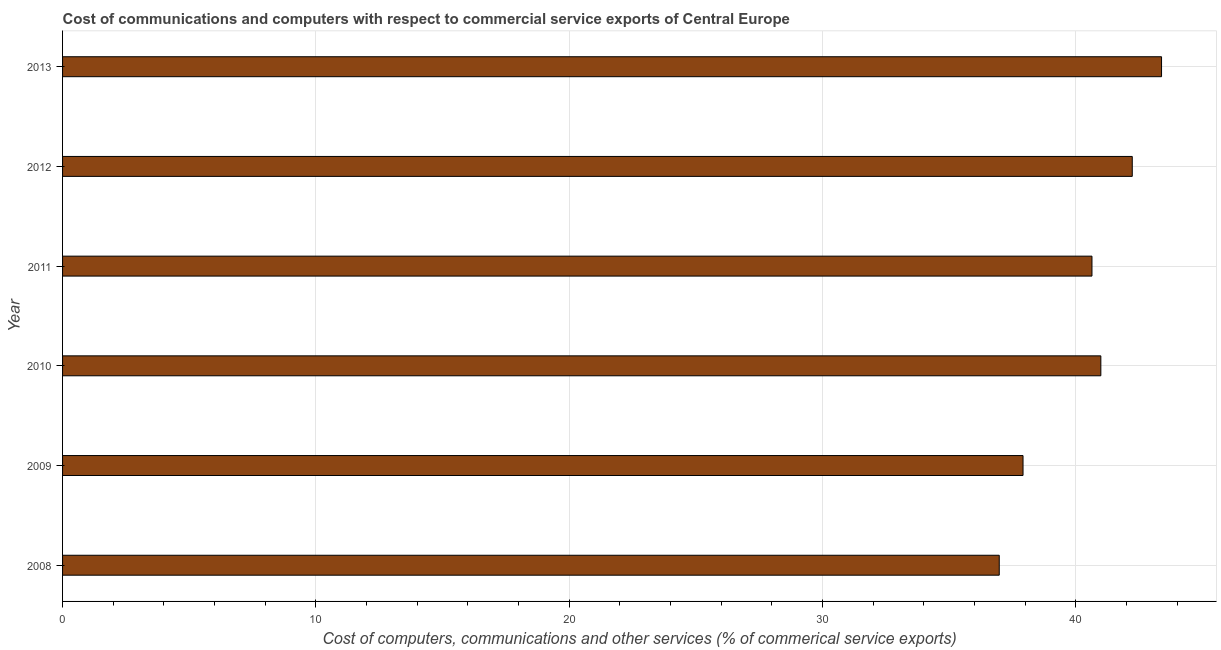Does the graph contain any zero values?
Your answer should be very brief. No. Does the graph contain grids?
Make the answer very short. Yes. What is the title of the graph?
Provide a succinct answer. Cost of communications and computers with respect to commercial service exports of Central Europe. What is the label or title of the X-axis?
Offer a very short reply. Cost of computers, communications and other services (% of commerical service exports). What is the cost of communications in 2010?
Offer a terse response. 40.99. Across all years, what is the maximum cost of communications?
Your response must be concise. 43.38. Across all years, what is the minimum  computer and other services?
Keep it short and to the point. 36.98. What is the sum of the  computer and other services?
Your response must be concise. 242.12. What is the difference between the  computer and other services in 2009 and 2011?
Your response must be concise. -2.72. What is the average cost of communications per year?
Provide a short and direct response. 40.35. What is the median  computer and other services?
Offer a terse response. 40.81. In how many years, is the cost of communications greater than 18 %?
Give a very brief answer. 6. Do a majority of the years between 2009 and 2011 (inclusive) have  computer and other services greater than 24 %?
Your answer should be very brief. Yes. What is the ratio of the  computer and other services in 2008 to that in 2010?
Provide a succinct answer. 0.9. Is the cost of communications in 2008 less than that in 2009?
Offer a very short reply. Yes. Is the difference between the  computer and other services in 2008 and 2009 greater than the difference between any two years?
Your response must be concise. No. What is the difference between the highest and the second highest  computer and other services?
Offer a very short reply. 1.16. Is the sum of the cost of communications in 2008 and 2010 greater than the maximum cost of communications across all years?
Offer a terse response. Yes. What is the difference between the highest and the lowest cost of communications?
Give a very brief answer. 6.41. In how many years, is the cost of communications greater than the average cost of communications taken over all years?
Your response must be concise. 4. Are all the bars in the graph horizontal?
Provide a short and direct response. Yes. What is the difference between two consecutive major ticks on the X-axis?
Give a very brief answer. 10. Are the values on the major ticks of X-axis written in scientific E-notation?
Provide a succinct answer. No. What is the Cost of computers, communications and other services (% of commerical service exports) of 2008?
Your response must be concise. 36.98. What is the Cost of computers, communications and other services (% of commerical service exports) in 2009?
Keep it short and to the point. 37.91. What is the Cost of computers, communications and other services (% of commerical service exports) of 2010?
Your response must be concise. 40.99. What is the Cost of computers, communications and other services (% of commerical service exports) of 2011?
Provide a succinct answer. 40.64. What is the Cost of computers, communications and other services (% of commerical service exports) in 2012?
Your response must be concise. 42.23. What is the Cost of computers, communications and other services (% of commerical service exports) of 2013?
Keep it short and to the point. 43.38. What is the difference between the Cost of computers, communications and other services (% of commerical service exports) in 2008 and 2009?
Your answer should be compact. -0.94. What is the difference between the Cost of computers, communications and other services (% of commerical service exports) in 2008 and 2010?
Give a very brief answer. -4.01. What is the difference between the Cost of computers, communications and other services (% of commerical service exports) in 2008 and 2011?
Offer a very short reply. -3.66. What is the difference between the Cost of computers, communications and other services (% of commerical service exports) in 2008 and 2012?
Ensure brevity in your answer.  -5.25. What is the difference between the Cost of computers, communications and other services (% of commerical service exports) in 2008 and 2013?
Keep it short and to the point. -6.41. What is the difference between the Cost of computers, communications and other services (% of commerical service exports) in 2009 and 2010?
Make the answer very short. -3.07. What is the difference between the Cost of computers, communications and other services (% of commerical service exports) in 2009 and 2011?
Provide a short and direct response. -2.72. What is the difference between the Cost of computers, communications and other services (% of commerical service exports) in 2009 and 2012?
Give a very brief answer. -4.31. What is the difference between the Cost of computers, communications and other services (% of commerical service exports) in 2009 and 2013?
Give a very brief answer. -5.47. What is the difference between the Cost of computers, communications and other services (% of commerical service exports) in 2010 and 2011?
Keep it short and to the point. 0.35. What is the difference between the Cost of computers, communications and other services (% of commerical service exports) in 2010 and 2012?
Make the answer very short. -1.24. What is the difference between the Cost of computers, communications and other services (% of commerical service exports) in 2010 and 2013?
Ensure brevity in your answer.  -2.4. What is the difference between the Cost of computers, communications and other services (% of commerical service exports) in 2011 and 2012?
Ensure brevity in your answer.  -1.59. What is the difference between the Cost of computers, communications and other services (% of commerical service exports) in 2011 and 2013?
Offer a terse response. -2.75. What is the difference between the Cost of computers, communications and other services (% of commerical service exports) in 2012 and 2013?
Offer a very short reply. -1.16. What is the ratio of the Cost of computers, communications and other services (% of commerical service exports) in 2008 to that in 2009?
Provide a succinct answer. 0.97. What is the ratio of the Cost of computers, communications and other services (% of commerical service exports) in 2008 to that in 2010?
Provide a short and direct response. 0.9. What is the ratio of the Cost of computers, communications and other services (% of commerical service exports) in 2008 to that in 2011?
Give a very brief answer. 0.91. What is the ratio of the Cost of computers, communications and other services (% of commerical service exports) in 2008 to that in 2012?
Your answer should be compact. 0.88. What is the ratio of the Cost of computers, communications and other services (% of commerical service exports) in 2008 to that in 2013?
Make the answer very short. 0.85. What is the ratio of the Cost of computers, communications and other services (% of commerical service exports) in 2009 to that in 2010?
Offer a terse response. 0.93. What is the ratio of the Cost of computers, communications and other services (% of commerical service exports) in 2009 to that in 2011?
Provide a succinct answer. 0.93. What is the ratio of the Cost of computers, communications and other services (% of commerical service exports) in 2009 to that in 2012?
Provide a succinct answer. 0.9. What is the ratio of the Cost of computers, communications and other services (% of commerical service exports) in 2009 to that in 2013?
Keep it short and to the point. 0.87. What is the ratio of the Cost of computers, communications and other services (% of commerical service exports) in 2010 to that in 2013?
Make the answer very short. 0.94. What is the ratio of the Cost of computers, communications and other services (% of commerical service exports) in 2011 to that in 2013?
Your answer should be very brief. 0.94. What is the ratio of the Cost of computers, communications and other services (% of commerical service exports) in 2012 to that in 2013?
Offer a terse response. 0.97. 